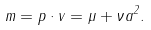Convert formula to latex. <formula><loc_0><loc_0><loc_500><loc_500>m = p \cdot v = \mu + \nu a ^ { 2 } .</formula> 